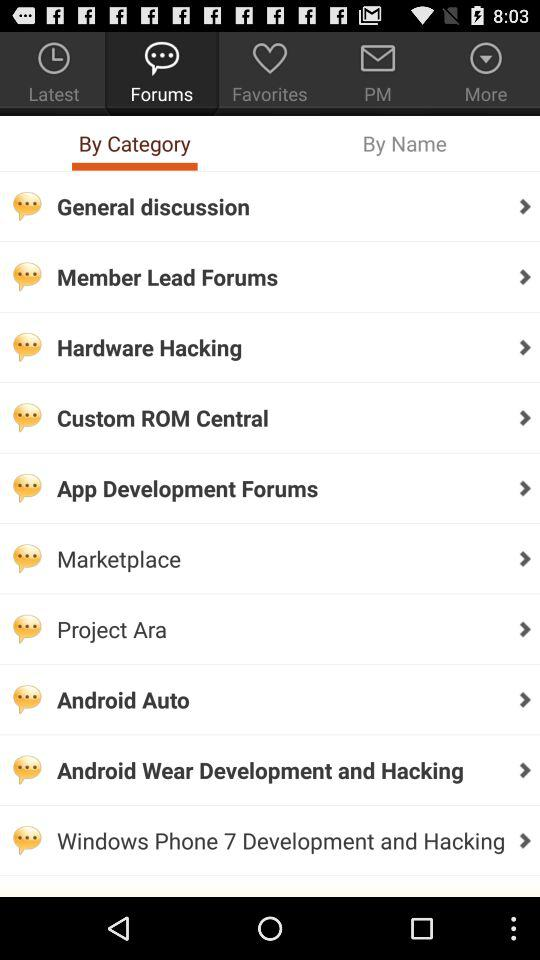Which one is selected out of "By Category" and "By Name"? The selected one is "By Category". 